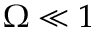<formula> <loc_0><loc_0><loc_500><loc_500>\Omega \ll 1</formula> 